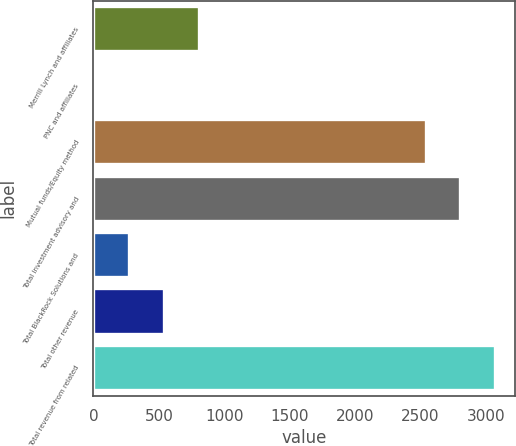Convert chart to OTSL. <chart><loc_0><loc_0><loc_500><loc_500><bar_chart><fcel>Merrill Lynch and affiliates<fcel>PNC and affiliates<fcel>Mutual funds/Equity method<fcel>Total investment advisory and<fcel>Total BlackRock Solutions and<fcel>Total other revenue<fcel>Total revenue from related<nl><fcel>805.2<fcel>9<fcel>2542<fcel>2807.4<fcel>274.4<fcel>539.8<fcel>3072.8<nl></chart> 